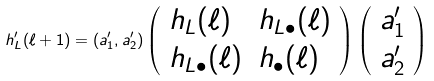<formula> <loc_0><loc_0><loc_500><loc_500>h ^ { \prime } _ { L } ( \ell + 1 ) = ( a ^ { \prime } _ { 1 } , a ^ { \prime } _ { 2 } ) \left ( \begin{array} { l l } h _ { L } ( \ell ) & h _ { L \bullet } ( \ell ) \\ h _ { L \bullet } ( \ell ) & h _ { \bullet } ( \ell ) \end{array} \right ) \left ( \begin{array} { c } a ^ { \prime } _ { 1 } \\ a ^ { \prime } _ { 2 } \end{array} \right )</formula> 